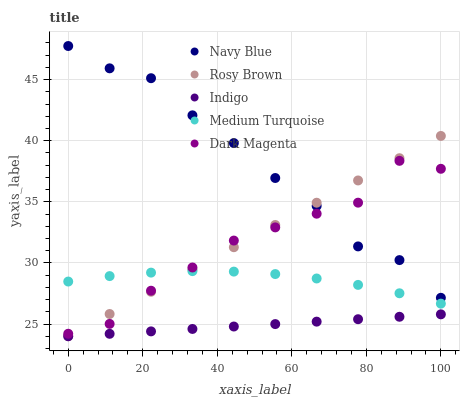Does Indigo have the minimum area under the curve?
Answer yes or no. Yes. Does Navy Blue have the maximum area under the curve?
Answer yes or no. Yes. Does Rosy Brown have the minimum area under the curve?
Answer yes or no. No. Does Rosy Brown have the maximum area under the curve?
Answer yes or no. No. Is Rosy Brown the smoothest?
Answer yes or no. Yes. Is Dark Magenta the roughest?
Answer yes or no. Yes. Is Indigo the smoothest?
Answer yes or no. No. Is Indigo the roughest?
Answer yes or no. No. Does Rosy Brown have the lowest value?
Answer yes or no. Yes. Does Dark Magenta have the lowest value?
Answer yes or no. No. Does Navy Blue have the highest value?
Answer yes or no. Yes. Does Rosy Brown have the highest value?
Answer yes or no. No. Is Indigo less than Medium Turquoise?
Answer yes or no. Yes. Is Navy Blue greater than Indigo?
Answer yes or no. Yes. Does Medium Turquoise intersect Dark Magenta?
Answer yes or no. Yes. Is Medium Turquoise less than Dark Magenta?
Answer yes or no. No. Is Medium Turquoise greater than Dark Magenta?
Answer yes or no. No. Does Indigo intersect Medium Turquoise?
Answer yes or no. No. 